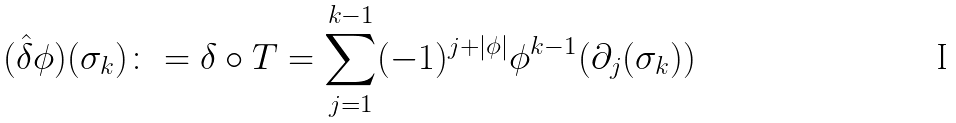Convert formula to latex. <formula><loc_0><loc_0><loc_500><loc_500>( \hat { \delta } \phi ) ( \sigma _ { k } ) \colon = \delta \circ T = \sum _ { j = 1 } ^ { k - 1 } ( - 1 ) ^ { j + | \phi | } \phi ^ { k - 1 } ( \partial _ { j } ( \sigma _ { k } ) )</formula> 